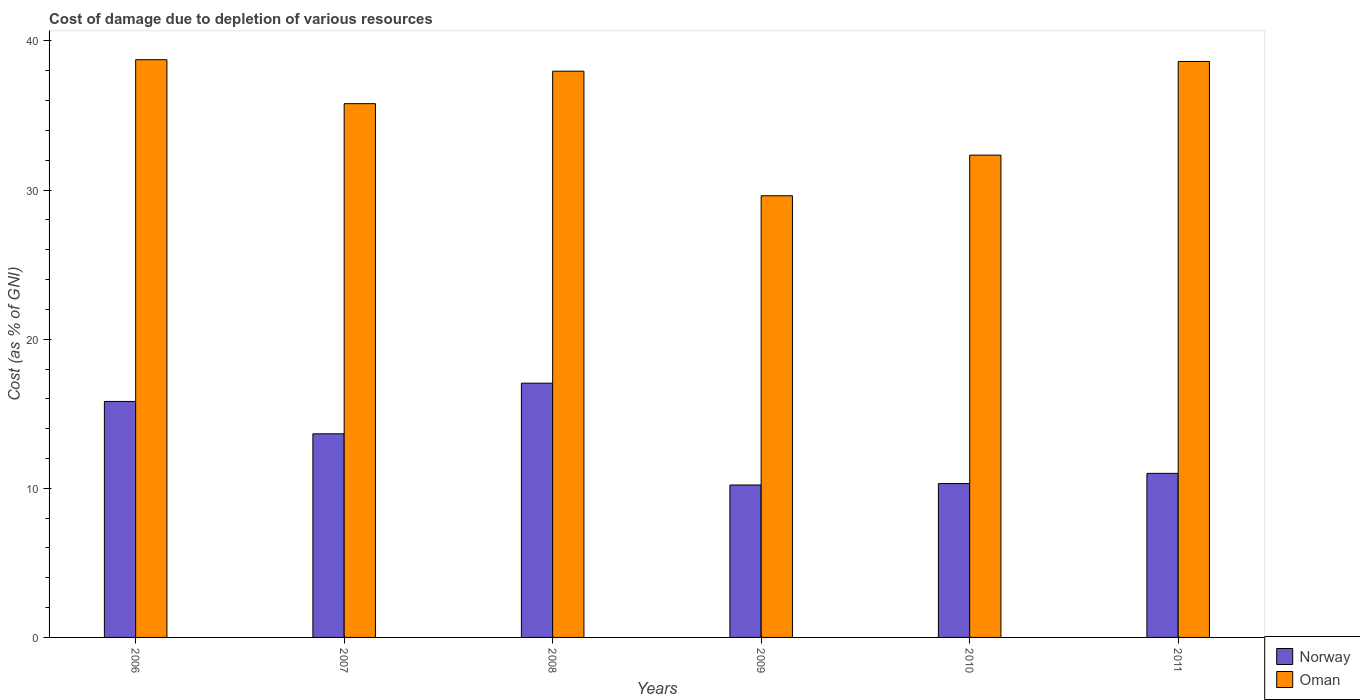How many different coloured bars are there?
Your answer should be compact. 2. How many groups of bars are there?
Your answer should be compact. 6. Are the number of bars on each tick of the X-axis equal?
Make the answer very short. Yes. How many bars are there on the 5th tick from the right?
Your response must be concise. 2. In how many cases, is the number of bars for a given year not equal to the number of legend labels?
Ensure brevity in your answer.  0. What is the cost of damage caused due to the depletion of various resources in Oman in 2007?
Make the answer very short. 35.79. Across all years, what is the maximum cost of damage caused due to the depletion of various resources in Oman?
Provide a succinct answer. 38.74. Across all years, what is the minimum cost of damage caused due to the depletion of various resources in Norway?
Give a very brief answer. 10.22. In which year was the cost of damage caused due to the depletion of various resources in Oman maximum?
Your response must be concise. 2006. What is the total cost of damage caused due to the depletion of various resources in Norway in the graph?
Offer a terse response. 78.07. What is the difference between the cost of damage caused due to the depletion of various resources in Norway in 2006 and that in 2009?
Your response must be concise. 5.6. What is the difference between the cost of damage caused due to the depletion of various resources in Oman in 2010 and the cost of damage caused due to the depletion of various resources in Norway in 2006?
Make the answer very short. 16.52. What is the average cost of damage caused due to the depletion of various resources in Norway per year?
Offer a terse response. 13.01. In the year 2009, what is the difference between the cost of damage caused due to the depletion of various resources in Norway and cost of damage caused due to the depletion of various resources in Oman?
Your response must be concise. -19.4. What is the ratio of the cost of damage caused due to the depletion of various resources in Norway in 2006 to that in 2009?
Keep it short and to the point. 1.55. Is the difference between the cost of damage caused due to the depletion of various resources in Norway in 2010 and 2011 greater than the difference between the cost of damage caused due to the depletion of various resources in Oman in 2010 and 2011?
Provide a short and direct response. Yes. What is the difference between the highest and the second highest cost of damage caused due to the depletion of various resources in Norway?
Make the answer very short. 1.22. What is the difference between the highest and the lowest cost of damage caused due to the depletion of various resources in Oman?
Give a very brief answer. 9.12. In how many years, is the cost of damage caused due to the depletion of various resources in Norway greater than the average cost of damage caused due to the depletion of various resources in Norway taken over all years?
Give a very brief answer. 3. Is the sum of the cost of damage caused due to the depletion of various resources in Norway in 2006 and 2009 greater than the maximum cost of damage caused due to the depletion of various resources in Oman across all years?
Provide a short and direct response. No. What does the 1st bar from the left in 2008 represents?
Offer a terse response. Norway. What does the 2nd bar from the right in 2010 represents?
Make the answer very short. Norway. How many years are there in the graph?
Keep it short and to the point. 6. What is the difference between two consecutive major ticks on the Y-axis?
Give a very brief answer. 10. Does the graph contain grids?
Offer a terse response. No. Where does the legend appear in the graph?
Your response must be concise. Bottom right. What is the title of the graph?
Give a very brief answer. Cost of damage due to depletion of various resources. What is the label or title of the Y-axis?
Keep it short and to the point. Cost (as % of GNI). What is the Cost (as % of GNI) of Norway in 2006?
Your answer should be very brief. 15.82. What is the Cost (as % of GNI) of Oman in 2006?
Provide a short and direct response. 38.74. What is the Cost (as % of GNI) in Norway in 2007?
Provide a succinct answer. 13.65. What is the Cost (as % of GNI) in Oman in 2007?
Give a very brief answer. 35.79. What is the Cost (as % of GNI) in Norway in 2008?
Keep it short and to the point. 17.05. What is the Cost (as % of GNI) in Oman in 2008?
Give a very brief answer. 37.97. What is the Cost (as % of GNI) in Norway in 2009?
Give a very brief answer. 10.22. What is the Cost (as % of GNI) in Oman in 2009?
Keep it short and to the point. 29.62. What is the Cost (as % of GNI) in Norway in 2010?
Offer a terse response. 10.32. What is the Cost (as % of GNI) in Oman in 2010?
Ensure brevity in your answer.  32.34. What is the Cost (as % of GNI) of Norway in 2011?
Your answer should be compact. 11. What is the Cost (as % of GNI) in Oman in 2011?
Keep it short and to the point. 38.62. Across all years, what is the maximum Cost (as % of GNI) in Norway?
Ensure brevity in your answer.  17.05. Across all years, what is the maximum Cost (as % of GNI) of Oman?
Offer a very short reply. 38.74. Across all years, what is the minimum Cost (as % of GNI) of Norway?
Your answer should be very brief. 10.22. Across all years, what is the minimum Cost (as % of GNI) of Oman?
Provide a succinct answer. 29.62. What is the total Cost (as % of GNI) in Norway in the graph?
Offer a terse response. 78.07. What is the total Cost (as % of GNI) of Oman in the graph?
Give a very brief answer. 213.09. What is the difference between the Cost (as % of GNI) of Norway in 2006 and that in 2007?
Your answer should be compact. 2.17. What is the difference between the Cost (as % of GNI) of Oman in 2006 and that in 2007?
Offer a very short reply. 2.95. What is the difference between the Cost (as % of GNI) in Norway in 2006 and that in 2008?
Make the answer very short. -1.23. What is the difference between the Cost (as % of GNI) of Oman in 2006 and that in 2008?
Offer a terse response. 0.77. What is the difference between the Cost (as % of GNI) of Norway in 2006 and that in 2009?
Make the answer very short. 5.6. What is the difference between the Cost (as % of GNI) of Oman in 2006 and that in 2009?
Your answer should be compact. 9.12. What is the difference between the Cost (as % of GNI) of Norway in 2006 and that in 2010?
Offer a very short reply. 5.51. What is the difference between the Cost (as % of GNI) in Oman in 2006 and that in 2010?
Your answer should be very brief. 6.4. What is the difference between the Cost (as % of GNI) in Norway in 2006 and that in 2011?
Offer a very short reply. 4.82. What is the difference between the Cost (as % of GNI) in Oman in 2006 and that in 2011?
Your response must be concise. 0.12. What is the difference between the Cost (as % of GNI) of Norway in 2007 and that in 2008?
Give a very brief answer. -3.4. What is the difference between the Cost (as % of GNI) of Oman in 2007 and that in 2008?
Ensure brevity in your answer.  -2.18. What is the difference between the Cost (as % of GNI) of Norway in 2007 and that in 2009?
Ensure brevity in your answer.  3.43. What is the difference between the Cost (as % of GNI) in Oman in 2007 and that in 2009?
Offer a very short reply. 6.18. What is the difference between the Cost (as % of GNI) in Norway in 2007 and that in 2010?
Your answer should be compact. 3.34. What is the difference between the Cost (as % of GNI) of Oman in 2007 and that in 2010?
Provide a succinct answer. 3.45. What is the difference between the Cost (as % of GNI) of Norway in 2007 and that in 2011?
Offer a very short reply. 2.65. What is the difference between the Cost (as % of GNI) of Oman in 2007 and that in 2011?
Ensure brevity in your answer.  -2.83. What is the difference between the Cost (as % of GNI) of Norway in 2008 and that in 2009?
Provide a succinct answer. 6.83. What is the difference between the Cost (as % of GNI) of Oman in 2008 and that in 2009?
Your response must be concise. 8.35. What is the difference between the Cost (as % of GNI) in Norway in 2008 and that in 2010?
Your response must be concise. 6.73. What is the difference between the Cost (as % of GNI) of Oman in 2008 and that in 2010?
Keep it short and to the point. 5.63. What is the difference between the Cost (as % of GNI) of Norway in 2008 and that in 2011?
Provide a short and direct response. 6.05. What is the difference between the Cost (as % of GNI) in Oman in 2008 and that in 2011?
Keep it short and to the point. -0.65. What is the difference between the Cost (as % of GNI) of Norway in 2009 and that in 2010?
Offer a terse response. -0.1. What is the difference between the Cost (as % of GNI) in Oman in 2009 and that in 2010?
Your response must be concise. -2.72. What is the difference between the Cost (as % of GNI) of Norway in 2009 and that in 2011?
Provide a short and direct response. -0.78. What is the difference between the Cost (as % of GNI) of Oman in 2009 and that in 2011?
Offer a terse response. -9. What is the difference between the Cost (as % of GNI) in Norway in 2010 and that in 2011?
Your response must be concise. -0.68. What is the difference between the Cost (as % of GNI) of Oman in 2010 and that in 2011?
Provide a short and direct response. -6.28. What is the difference between the Cost (as % of GNI) of Norway in 2006 and the Cost (as % of GNI) of Oman in 2007?
Offer a very short reply. -19.97. What is the difference between the Cost (as % of GNI) of Norway in 2006 and the Cost (as % of GNI) of Oman in 2008?
Offer a very short reply. -22.15. What is the difference between the Cost (as % of GNI) in Norway in 2006 and the Cost (as % of GNI) in Oman in 2009?
Your response must be concise. -13.79. What is the difference between the Cost (as % of GNI) in Norway in 2006 and the Cost (as % of GNI) in Oman in 2010?
Give a very brief answer. -16.52. What is the difference between the Cost (as % of GNI) in Norway in 2006 and the Cost (as % of GNI) in Oman in 2011?
Provide a succinct answer. -22.8. What is the difference between the Cost (as % of GNI) in Norway in 2007 and the Cost (as % of GNI) in Oman in 2008?
Make the answer very short. -24.32. What is the difference between the Cost (as % of GNI) of Norway in 2007 and the Cost (as % of GNI) of Oman in 2009?
Your answer should be very brief. -15.96. What is the difference between the Cost (as % of GNI) of Norway in 2007 and the Cost (as % of GNI) of Oman in 2010?
Ensure brevity in your answer.  -18.69. What is the difference between the Cost (as % of GNI) of Norway in 2007 and the Cost (as % of GNI) of Oman in 2011?
Provide a short and direct response. -24.97. What is the difference between the Cost (as % of GNI) in Norway in 2008 and the Cost (as % of GNI) in Oman in 2009?
Give a very brief answer. -12.57. What is the difference between the Cost (as % of GNI) in Norway in 2008 and the Cost (as % of GNI) in Oman in 2010?
Keep it short and to the point. -15.29. What is the difference between the Cost (as % of GNI) of Norway in 2008 and the Cost (as % of GNI) of Oman in 2011?
Offer a terse response. -21.57. What is the difference between the Cost (as % of GNI) of Norway in 2009 and the Cost (as % of GNI) of Oman in 2010?
Keep it short and to the point. -22.12. What is the difference between the Cost (as % of GNI) of Norway in 2009 and the Cost (as % of GNI) of Oman in 2011?
Keep it short and to the point. -28.4. What is the difference between the Cost (as % of GNI) of Norway in 2010 and the Cost (as % of GNI) of Oman in 2011?
Your answer should be very brief. -28.31. What is the average Cost (as % of GNI) in Norway per year?
Offer a terse response. 13.01. What is the average Cost (as % of GNI) of Oman per year?
Keep it short and to the point. 35.51. In the year 2006, what is the difference between the Cost (as % of GNI) in Norway and Cost (as % of GNI) in Oman?
Your answer should be very brief. -22.92. In the year 2007, what is the difference between the Cost (as % of GNI) of Norway and Cost (as % of GNI) of Oman?
Ensure brevity in your answer.  -22.14. In the year 2008, what is the difference between the Cost (as % of GNI) in Norway and Cost (as % of GNI) in Oman?
Ensure brevity in your answer.  -20.92. In the year 2009, what is the difference between the Cost (as % of GNI) in Norway and Cost (as % of GNI) in Oman?
Your answer should be very brief. -19.4. In the year 2010, what is the difference between the Cost (as % of GNI) in Norway and Cost (as % of GNI) in Oman?
Your response must be concise. -22.02. In the year 2011, what is the difference between the Cost (as % of GNI) in Norway and Cost (as % of GNI) in Oman?
Keep it short and to the point. -27.62. What is the ratio of the Cost (as % of GNI) of Norway in 2006 to that in 2007?
Keep it short and to the point. 1.16. What is the ratio of the Cost (as % of GNI) in Oman in 2006 to that in 2007?
Ensure brevity in your answer.  1.08. What is the ratio of the Cost (as % of GNI) of Norway in 2006 to that in 2008?
Offer a terse response. 0.93. What is the ratio of the Cost (as % of GNI) of Oman in 2006 to that in 2008?
Keep it short and to the point. 1.02. What is the ratio of the Cost (as % of GNI) of Norway in 2006 to that in 2009?
Provide a short and direct response. 1.55. What is the ratio of the Cost (as % of GNI) in Oman in 2006 to that in 2009?
Ensure brevity in your answer.  1.31. What is the ratio of the Cost (as % of GNI) of Norway in 2006 to that in 2010?
Offer a terse response. 1.53. What is the ratio of the Cost (as % of GNI) of Oman in 2006 to that in 2010?
Keep it short and to the point. 1.2. What is the ratio of the Cost (as % of GNI) in Norway in 2006 to that in 2011?
Ensure brevity in your answer.  1.44. What is the ratio of the Cost (as % of GNI) of Norway in 2007 to that in 2008?
Make the answer very short. 0.8. What is the ratio of the Cost (as % of GNI) in Oman in 2007 to that in 2008?
Provide a short and direct response. 0.94. What is the ratio of the Cost (as % of GNI) in Norway in 2007 to that in 2009?
Keep it short and to the point. 1.34. What is the ratio of the Cost (as % of GNI) of Oman in 2007 to that in 2009?
Provide a short and direct response. 1.21. What is the ratio of the Cost (as % of GNI) in Norway in 2007 to that in 2010?
Ensure brevity in your answer.  1.32. What is the ratio of the Cost (as % of GNI) in Oman in 2007 to that in 2010?
Provide a short and direct response. 1.11. What is the ratio of the Cost (as % of GNI) of Norway in 2007 to that in 2011?
Keep it short and to the point. 1.24. What is the ratio of the Cost (as % of GNI) of Oman in 2007 to that in 2011?
Offer a very short reply. 0.93. What is the ratio of the Cost (as % of GNI) in Norway in 2008 to that in 2009?
Offer a terse response. 1.67. What is the ratio of the Cost (as % of GNI) of Oman in 2008 to that in 2009?
Provide a succinct answer. 1.28. What is the ratio of the Cost (as % of GNI) of Norway in 2008 to that in 2010?
Keep it short and to the point. 1.65. What is the ratio of the Cost (as % of GNI) of Oman in 2008 to that in 2010?
Ensure brevity in your answer.  1.17. What is the ratio of the Cost (as % of GNI) of Norway in 2008 to that in 2011?
Give a very brief answer. 1.55. What is the ratio of the Cost (as % of GNI) of Oman in 2008 to that in 2011?
Your answer should be very brief. 0.98. What is the ratio of the Cost (as % of GNI) in Norway in 2009 to that in 2010?
Provide a succinct answer. 0.99. What is the ratio of the Cost (as % of GNI) of Oman in 2009 to that in 2010?
Your answer should be compact. 0.92. What is the ratio of the Cost (as % of GNI) of Norway in 2009 to that in 2011?
Ensure brevity in your answer.  0.93. What is the ratio of the Cost (as % of GNI) in Oman in 2009 to that in 2011?
Provide a succinct answer. 0.77. What is the ratio of the Cost (as % of GNI) of Norway in 2010 to that in 2011?
Provide a succinct answer. 0.94. What is the ratio of the Cost (as % of GNI) of Oman in 2010 to that in 2011?
Offer a terse response. 0.84. What is the difference between the highest and the second highest Cost (as % of GNI) in Norway?
Offer a terse response. 1.23. What is the difference between the highest and the second highest Cost (as % of GNI) in Oman?
Keep it short and to the point. 0.12. What is the difference between the highest and the lowest Cost (as % of GNI) of Norway?
Your answer should be compact. 6.83. What is the difference between the highest and the lowest Cost (as % of GNI) of Oman?
Your answer should be compact. 9.12. 